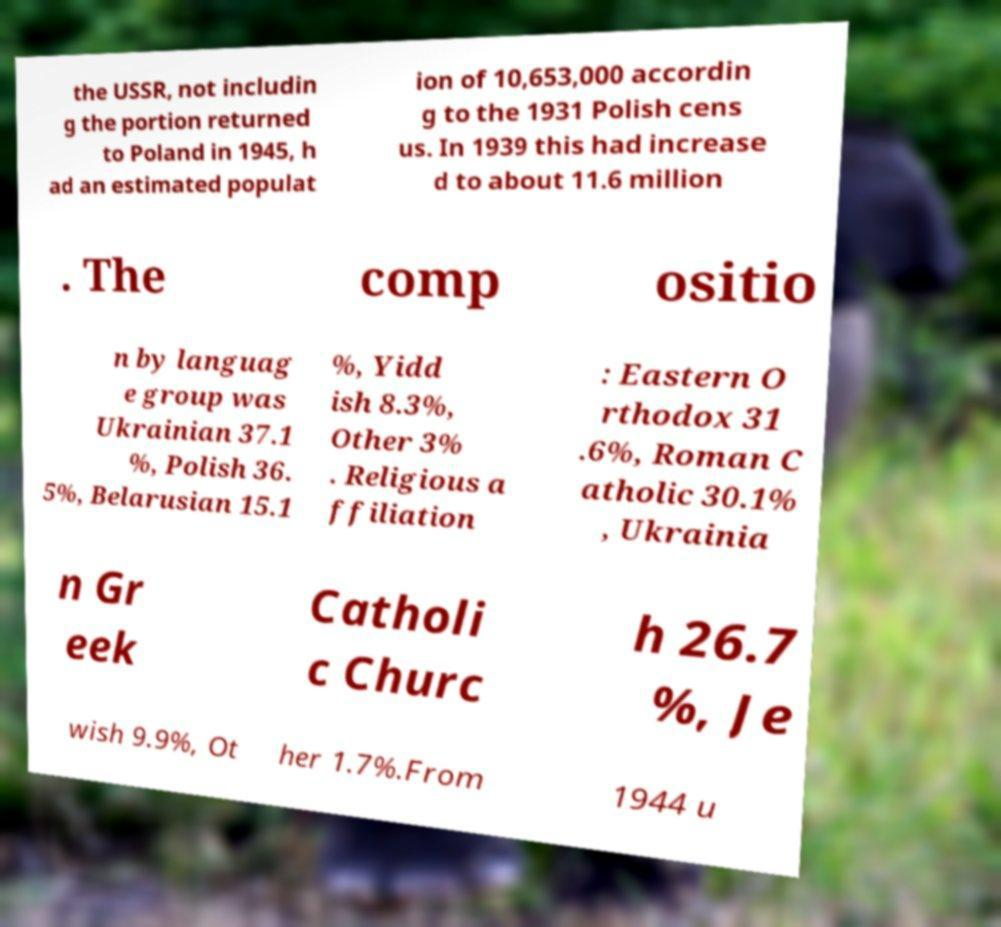Could you extract and type out the text from this image? the USSR, not includin g the portion returned to Poland in 1945, h ad an estimated populat ion of 10,653,000 accordin g to the 1931 Polish cens us. In 1939 this had increase d to about 11.6 million . The comp ositio n by languag e group was Ukrainian 37.1 %, Polish 36. 5%, Belarusian 15.1 %, Yidd ish 8.3%, Other 3% . Religious a ffiliation : Eastern O rthodox 31 .6%, Roman C atholic 30.1% , Ukrainia n Gr eek Catholi c Churc h 26.7 %, Je wish 9.9%, Ot her 1.7%.From 1944 u 